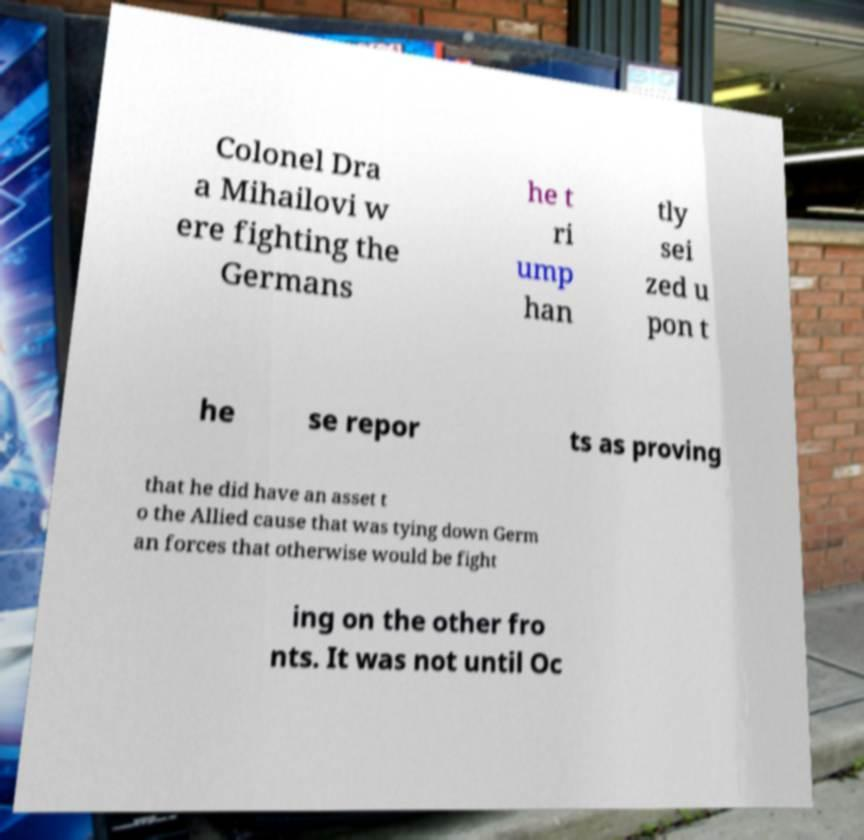For documentation purposes, I need the text within this image transcribed. Could you provide that? Colonel Dra a Mihailovi w ere fighting the Germans he t ri ump han tly sei zed u pon t he se repor ts as proving that he did have an asset t o the Allied cause that was tying down Germ an forces that otherwise would be fight ing on the other fro nts. It was not until Oc 